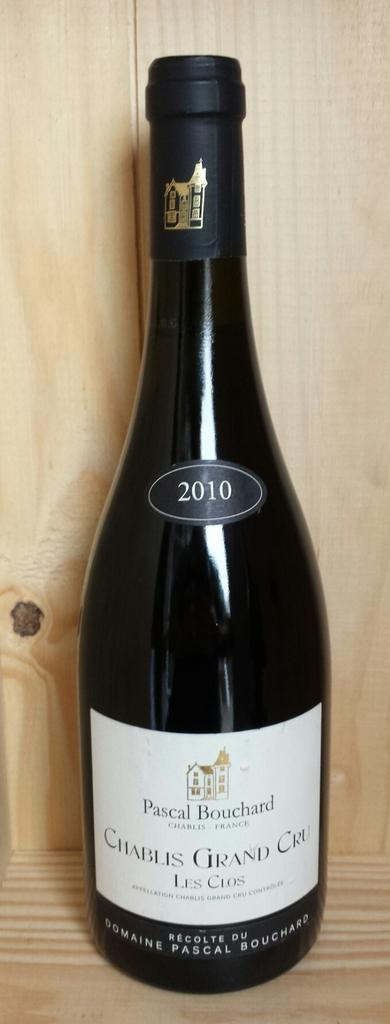<image>
Share a concise interpretation of the image provided. A bottle has 2010 on it with the label Chablis Grand Bouchard at the bottom. 